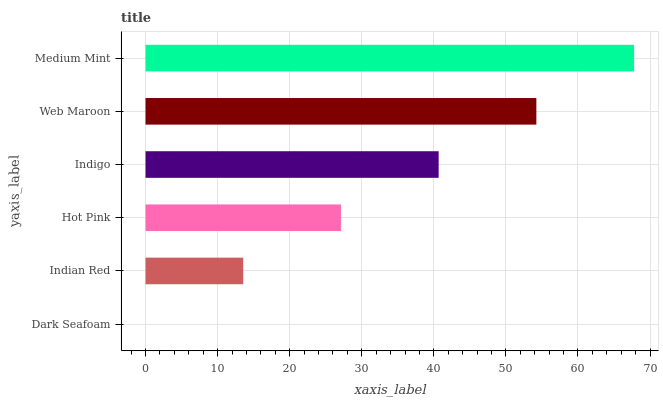Is Dark Seafoam the minimum?
Answer yes or no. Yes. Is Medium Mint the maximum?
Answer yes or no. Yes. Is Indian Red the minimum?
Answer yes or no. No. Is Indian Red the maximum?
Answer yes or no. No. Is Indian Red greater than Dark Seafoam?
Answer yes or no. Yes. Is Dark Seafoam less than Indian Red?
Answer yes or no. Yes. Is Dark Seafoam greater than Indian Red?
Answer yes or no. No. Is Indian Red less than Dark Seafoam?
Answer yes or no. No. Is Indigo the high median?
Answer yes or no. Yes. Is Hot Pink the low median?
Answer yes or no. Yes. Is Dark Seafoam the high median?
Answer yes or no. No. Is Web Maroon the low median?
Answer yes or no. No. 